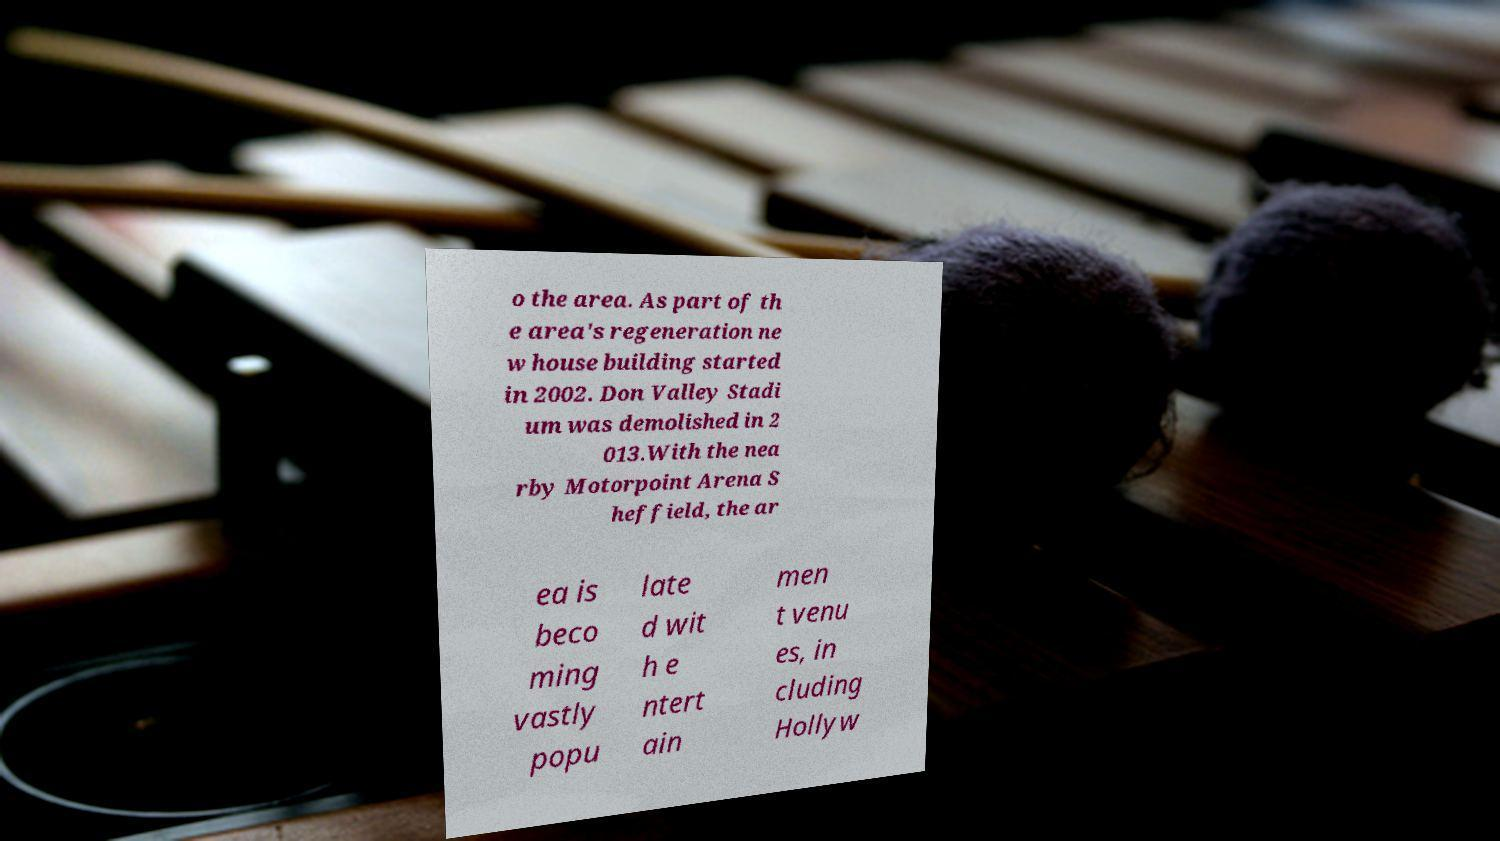For documentation purposes, I need the text within this image transcribed. Could you provide that? o the area. As part of th e area's regeneration ne w house building started in 2002. Don Valley Stadi um was demolished in 2 013.With the nea rby Motorpoint Arena S heffield, the ar ea is beco ming vastly popu late d wit h e ntert ain men t venu es, in cluding Hollyw 